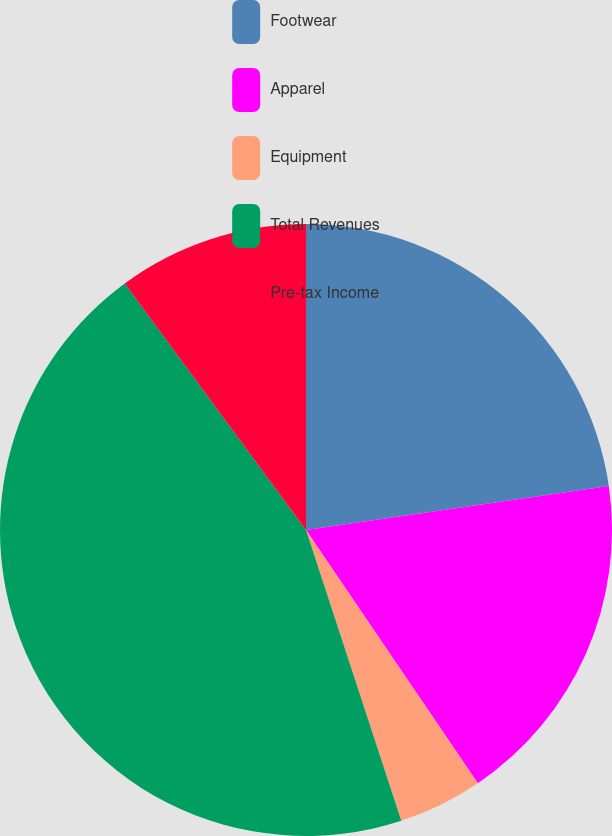<chart> <loc_0><loc_0><loc_500><loc_500><pie_chart><fcel>Footwear<fcel>Apparel<fcel>Equipment<fcel>Total Revenues<fcel>Pre-tax Income<nl><fcel>22.7%<fcel>17.81%<fcel>4.45%<fcel>44.95%<fcel>10.09%<nl></chart> 